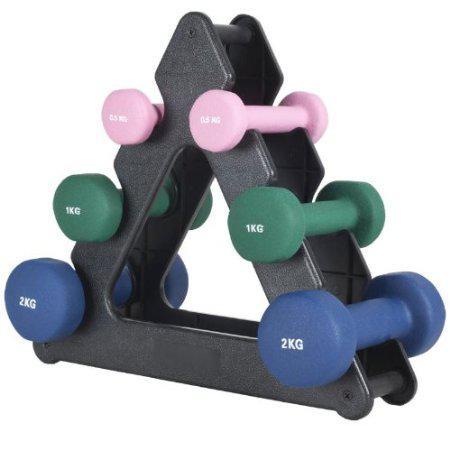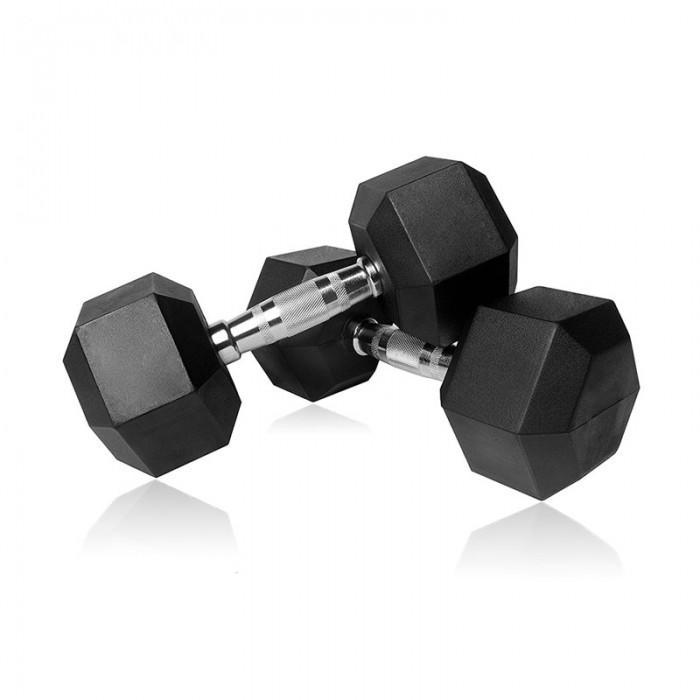The first image is the image on the left, the second image is the image on the right. Assess this claim about the two images: "There are two blue dumbbells.". Correct or not? Answer yes or no. Yes. The first image is the image on the left, the second image is the image on the right. For the images displayed, is the sentence "In the image to the right, there is only one pair of free weights." factually correct? Answer yes or no. Yes. 